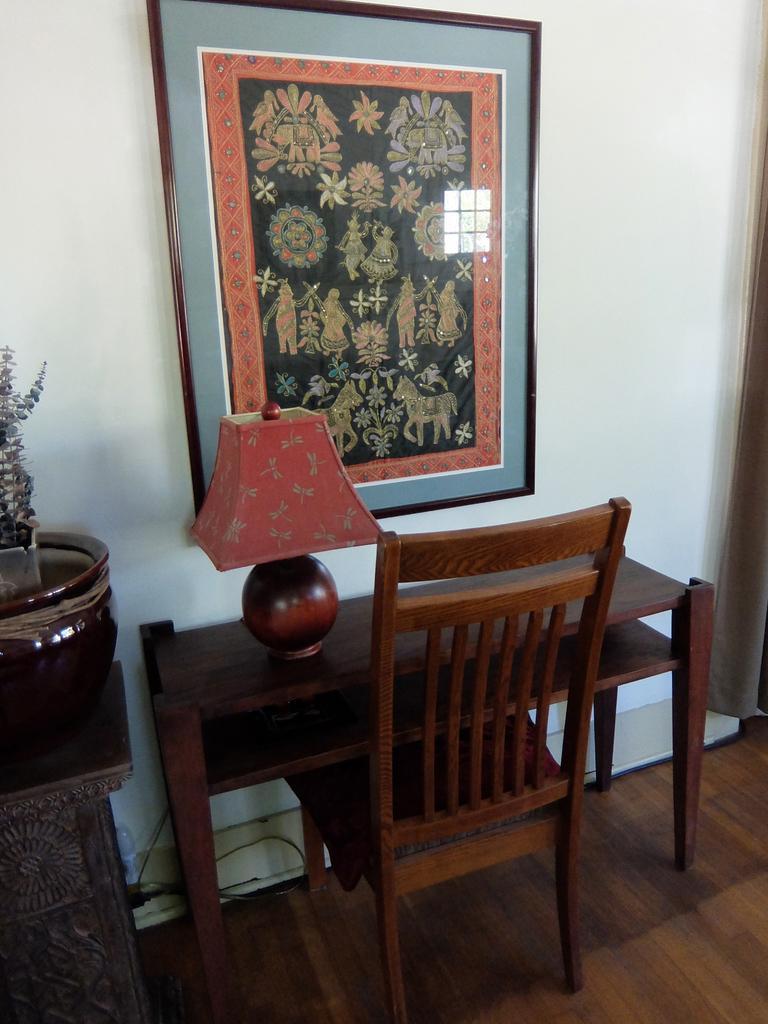In one or two sentences, can you explain what this image depicts? In this picture I can see there is a table, chair and there is a lamp and there is a flower pot at left side and there is a photo frame on the wall. 